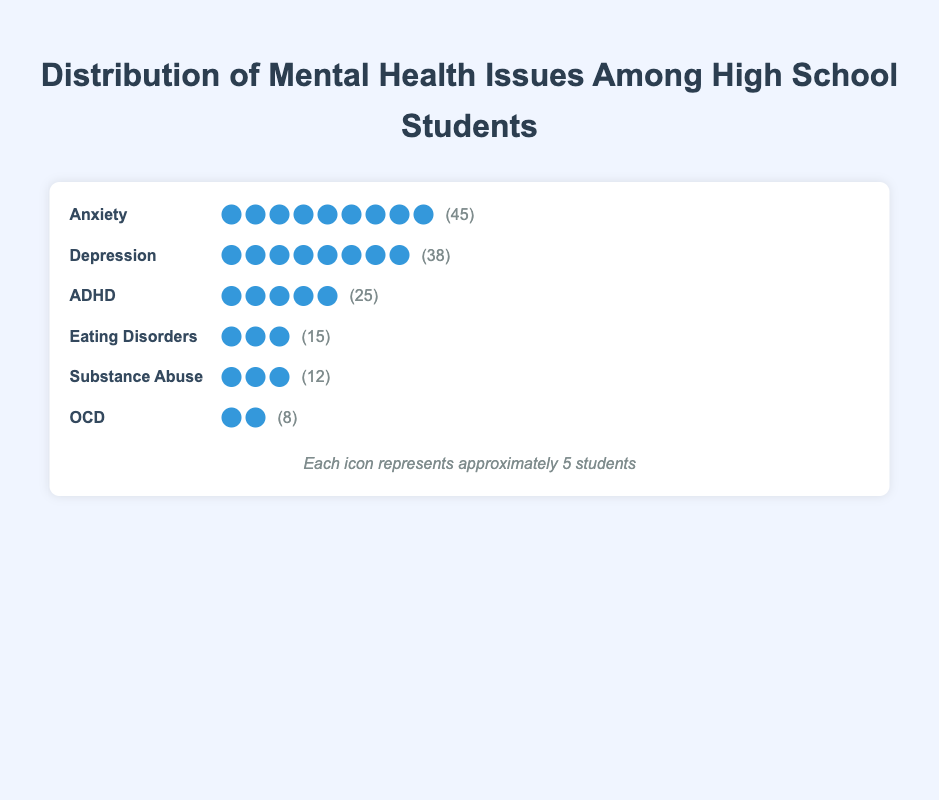How many students are represented by each icon? Each icon is mentioned in the legend as representing approximately 5 students.
Answer: 5 students Which type of disorder has the highest number of affected students? By looking at the rows, the "Anxiety" disorder has the longest row of icons, indicating it affects the highest number of students (45 students).
Answer: Anxiety What is the total number of students diagnosed with ADHD and OCD combined? Add the number of students for ADHD (25) and OCD (8). The total is 25 + 8 = 33.
Answer: 33 How does the number of students with Depression compare to those with Substance Abuse? Depression affects 38 students, while Substance Abuse affects 12 students. 38 is significantly greater than 12.
Answer: Depression affects more students What percentage of the total cases represented are those with Eating Disorders? First, find the total number of students affected: 45 (Anxiety) + 38 (Depression) + 25 (ADHD) + 15 (Eating Disorders) + 12 (Substance Abuse) + 8 (OCD) = 143. Then, calculate the percentage for Eating Disorders 15/143 * 100 ≈ 10.49%.
Answer: About 10.49% If an icon represents approximately 5 students, how many icons should appear for Substance Abuse? Divide the number of students (12) by the number of students each icon represents (5). 12/5 = 2.4. Since it's an approximation, it rounds to 3 icons in the visual representation.
Answer: 3 icons Which disorder affects fewer students, OCD or Eating Disorders? Compare the counts: OCD (8 students) and Eating Disorders (15 students). 8 is less than 15.
Answer: OCD What is the combined number of students diagnosed with Anxiety, Depression, and Substance Abuse? Add the number of students for Anxiety (45), Depression (38), and Substance Abuse (12): 45 + 38 + 12 = 95.
Answer: 95 Is the number of students with Anxiety more than double those with ADHD? First, find double the number of students with ADHD: 25 * 2 = 50. Since 45 (Anxiety) is less than 50, Anxiety is not more than double ADHD.
Answer: No How many mental health disorders are represented in the plot? Count the different types of disorders listed in the plot: Anxiety, Depression, ADHD, Eating Disorders, Substance Abuse, and OCD. There are 6 different disorders.
Answer: 6 